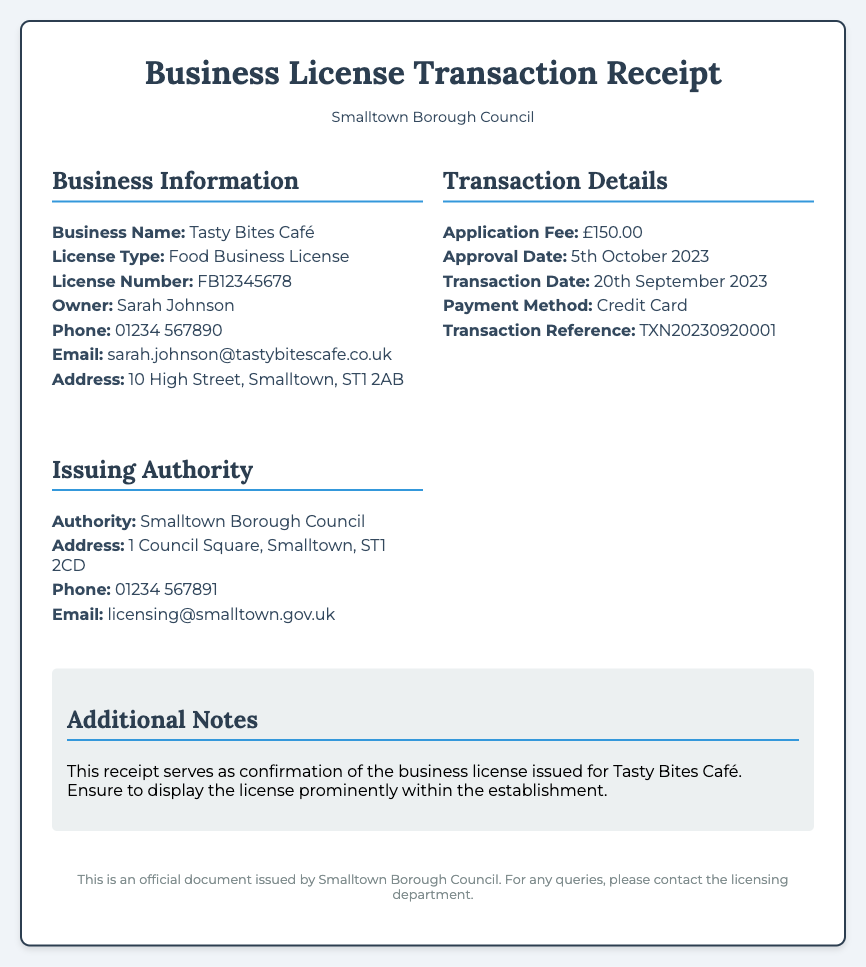what is the business name? The business name is specified in the Business Information section of the document.
Answer: Tasty Bites Café what type of license was issued? The type of license is listed in the Business Information section, indicating what kind of business it relates to.
Answer: Food Business License what is the application fee amount? The application fee is detailed in the Transaction Details section of the document.
Answer: £150.00 when was the approval date? The approval date is found in the Transaction Details section and indicates when the license was granted.
Answer: 5th October 2023 who is the owner of the business? The owner's name is presented in the Business Information section under the respective label.
Answer: Sarah Johnson what is the transaction date? The transaction date indicates when the application and payment were processed, found in the Transaction Details section.
Answer: 20th September 2023 what is the transaction reference number? The transaction reference number is listed in the Transaction Details section, serving as a unique identifier.
Answer: TXN20230920001 which authority issued the license? The licensing authority is mentioned in the Issuing Authority section of the document, indicating who authorized the license.
Answer: Smalltown Borough Council what should be done with the receipt? The Additional Notes section specifies the intended use of the receipt after the transaction.
Answer: Ensure to display the license prominently within the establishment 